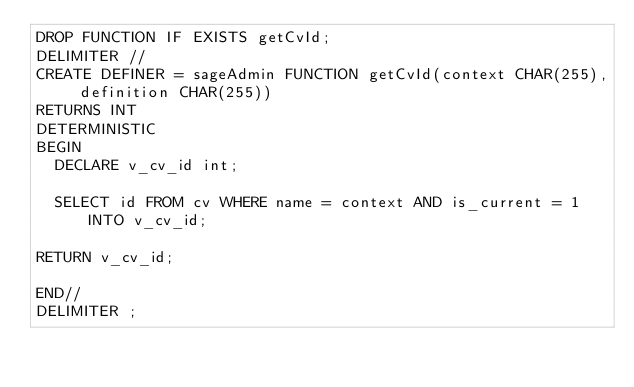Convert code to text. <code><loc_0><loc_0><loc_500><loc_500><_SQL_>DROP FUNCTION IF EXISTS getCvId;
DELIMITER //
CREATE DEFINER = sageAdmin FUNCTION getCvId(context CHAR(255), definition CHAR(255))
RETURNS INT
DETERMINISTIC
BEGIN
  DECLARE v_cv_id int;

  SELECT id FROM cv WHERE name = context AND is_current = 1 INTO v_cv_id;

RETURN v_cv_id;

END//
DELIMITER ;
</code> 